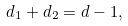<formula> <loc_0><loc_0><loc_500><loc_500>d _ { 1 } + d _ { 2 } = d - 1 ,</formula> 